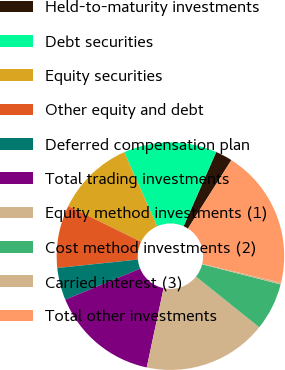<chart> <loc_0><loc_0><loc_500><loc_500><pie_chart><fcel>Held-to-maturity investments<fcel>Debt securities<fcel>Equity securities<fcel>Other equity and debt<fcel>Deferred compensation plan<fcel>Total trading investments<fcel>Equity method investments (1)<fcel>Cost method investments (2)<fcel>Carried interest (3)<fcel>Total other investments<nl><fcel>2.41%<fcel>13.25%<fcel>11.08%<fcel>8.92%<fcel>4.58%<fcel>15.42%<fcel>17.59%<fcel>6.75%<fcel>0.25%<fcel>19.75%<nl></chart> 